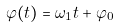<formula> <loc_0><loc_0><loc_500><loc_500>\varphi ( t ) = \omega _ { 1 } t + \varphi _ { 0 }</formula> 